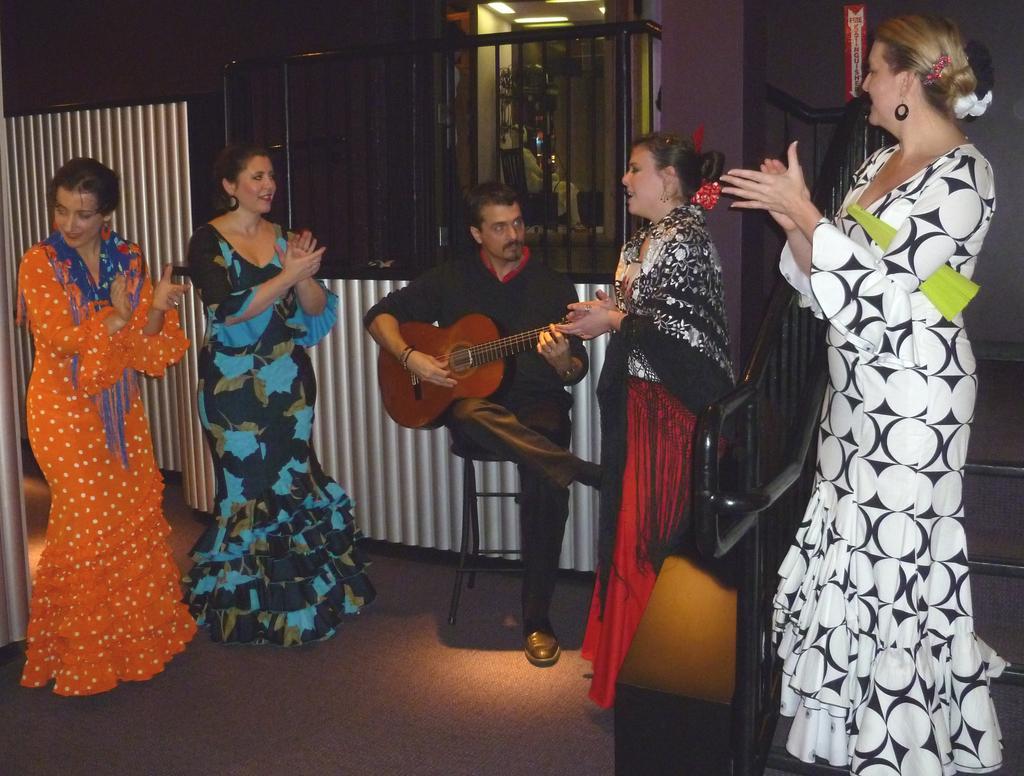Can you describe this image briefly? The picture is taken in a closed room where at the right corner the woman is standing in a white and black dress on the stairs beside her another woman is wearing a dress in red and black and singing, beside her a man is sitting on the chair and playing a guitar and at the right corner of the picture a woman is dressed in orange colour and beside her another woman is dressed in blue and black colour and behind them there is a house. 